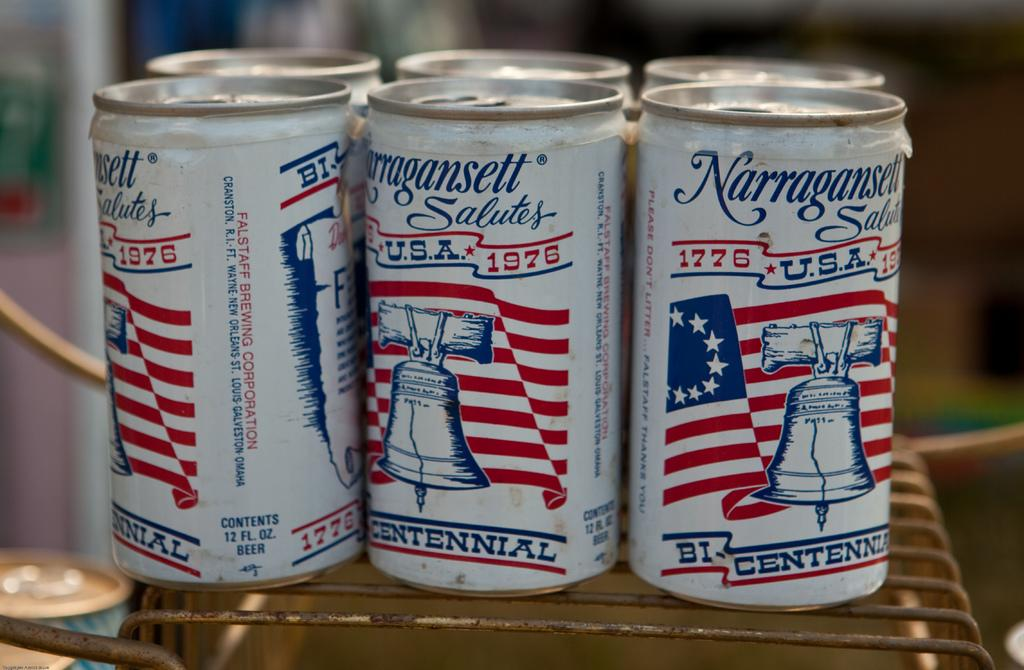<image>
Render a clear and concise summary of the photo. A six pack of Narragansett has a red, white and blue bi-centennial theme. 